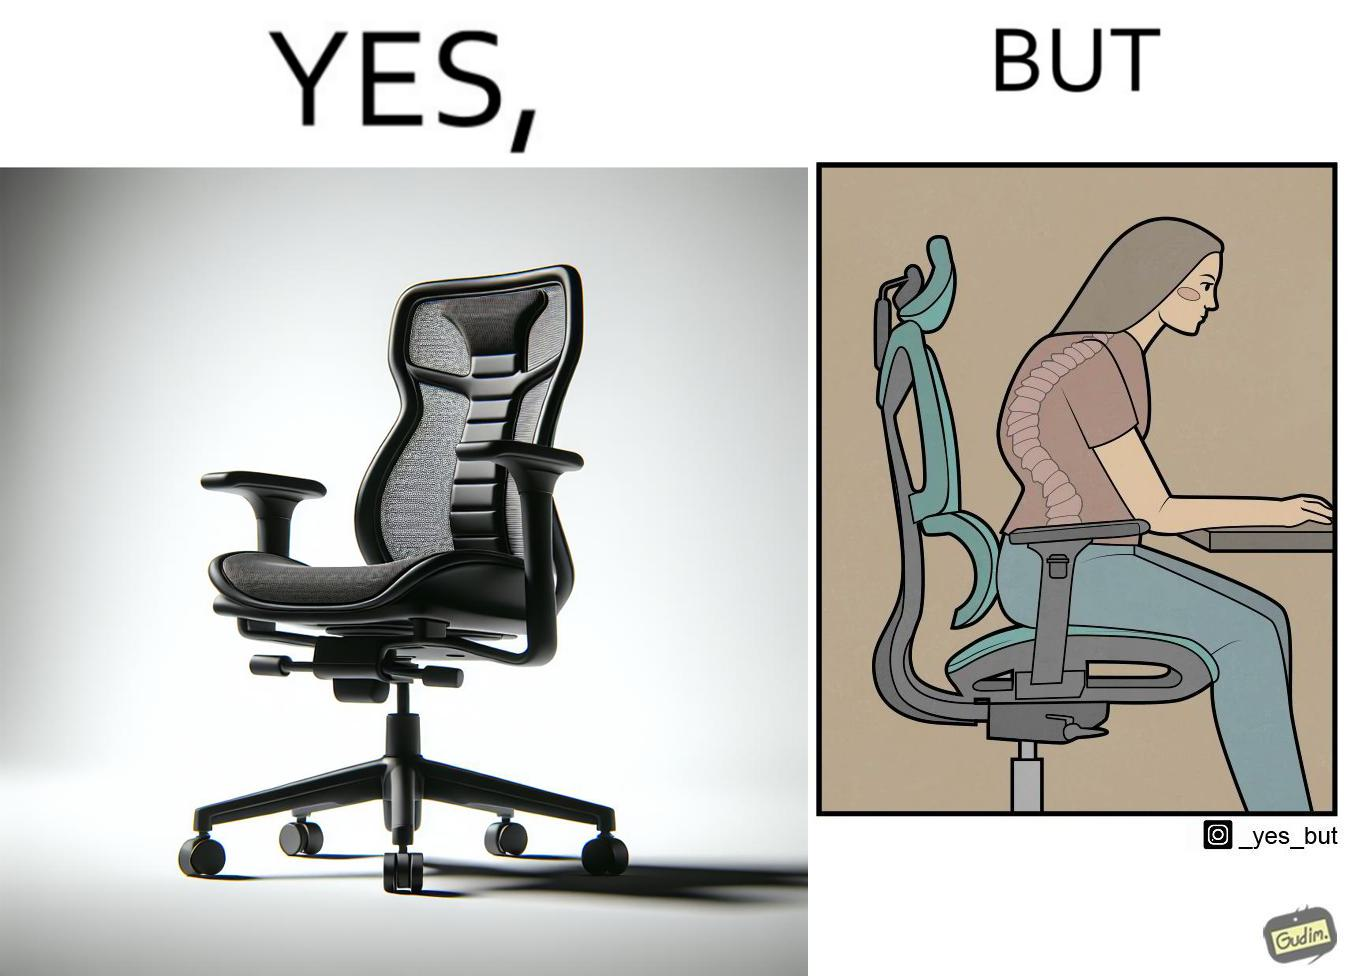Why is this image considered satirical? The image is ironical, as even though the ergonomic chair is meant to facilitate an upright and comfortable posture for the person sitting on it, the person sitting on it still has a bent posture, as the person is not utilizing the backrest. 